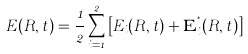<formula> <loc_0><loc_0><loc_500><loc_500>E ( R , t ) = \frac { 1 } { 2 } \sum _ { i = 1 } ^ { 2 } \left [ E _ { i } ( R , t ) + \mathbf E ^ { ^ { * } } _ { i } ( R , t ) \right ]</formula> 